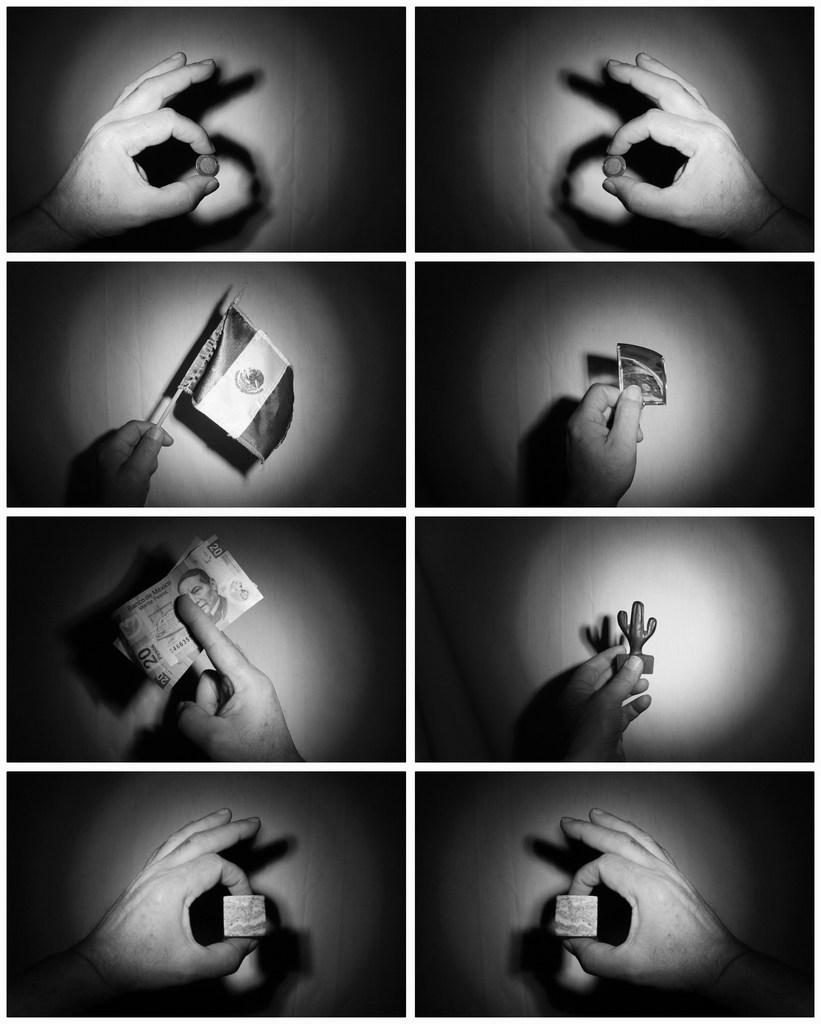What type of picture is in the image? There is a collage picture in the image. Whose hands are visible in the image? A person's hands are visible in the image. What is the flag associated with in the image? There is a flag in the image. What type of financial instrument is present in the image? A currency note is present in the image. Can you describe any other objects in the image? There are additional objects in the image. What type of skin condition can be seen on the person's hands in the image? There is no indication of a skin condition on the person's hands in the image. What type of waste is being disposed of in the image? There is no waste being disposed of in the image. 